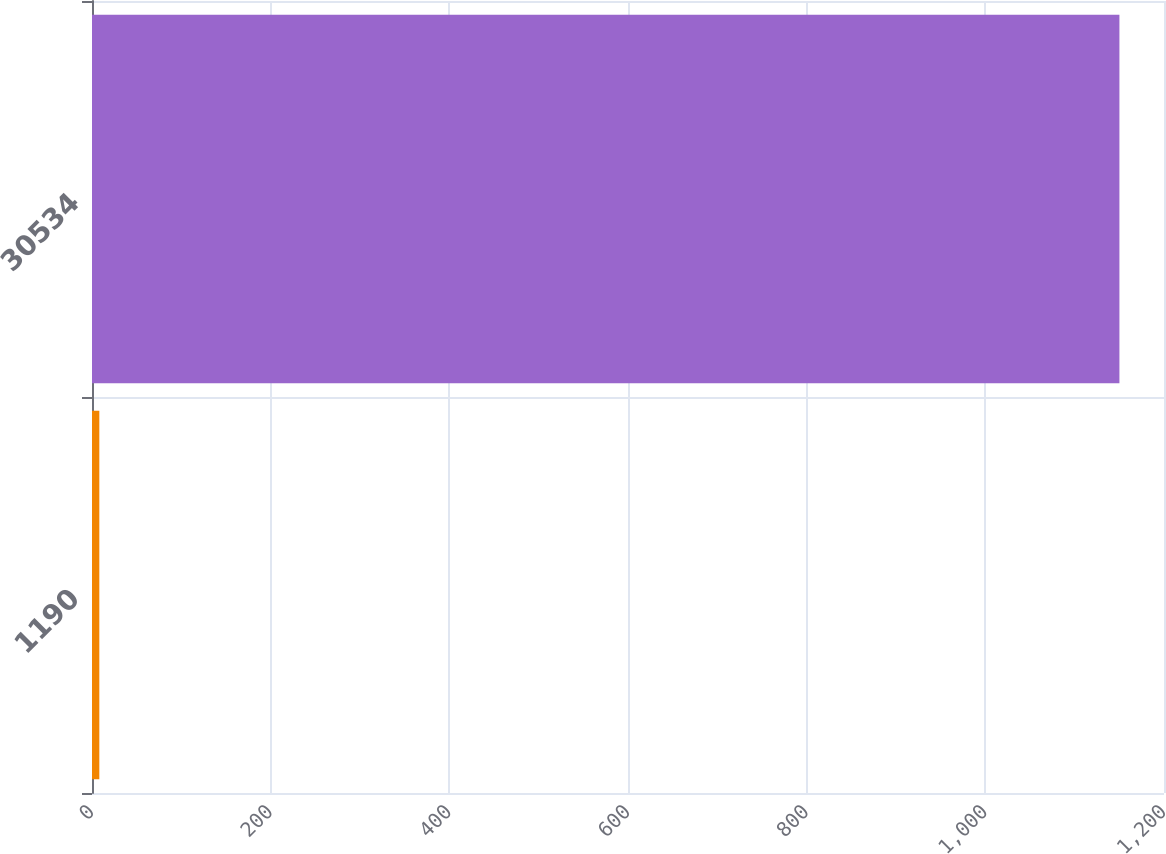Convert chart. <chart><loc_0><loc_0><loc_500><loc_500><bar_chart><fcel>1190<fcel>30534<nl><fcel>8.2<fcel>1150.1<nl></chart> 